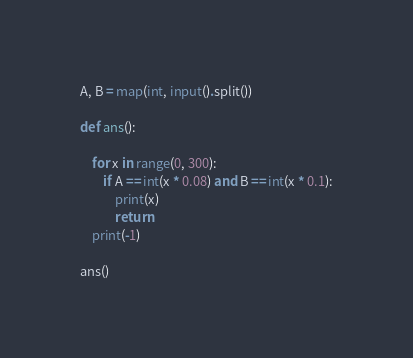Convert code to text. <code><loc_0><loc_0><loc_500><loc_500><_Python_>A, B = map(int, input().split())

def ans():

    for x in range(0, 300):
        if A == int(x * 0.08) and B == int(x * 0.1):
            print(x)
            return
    print(-1)

ans()</code> 